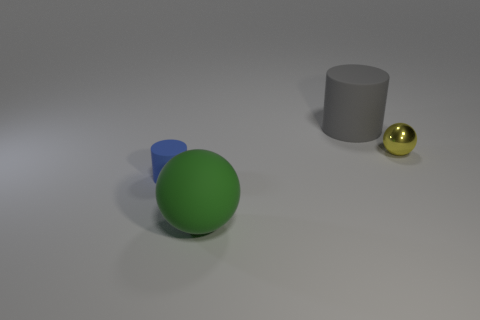Is there anything else that has the same color as the big matte ball?
Offer a terse response. No. What number of rubber things are tiny blue things or green spheres?
Make the answer very short. 2. What is the size of the thing that is both in front of the big gray matte cylinder and behind the small rubber cylinder?
Offer a very short reply. Small. There is a big object that is in front of the small blue cylinder; is there a tiny blue rubber cylinder that is on the left side of it?
Ensure brevity in your answer.  Yes. There is a big gray matte object; what number of small shiny balls are on the right side of it?
Provide a succinct answer. 1. There is a large rubber object that is the same shape as the small blue object; what color is it?
Ensure brevity in your answer.  Gray. Do the cylinder that is behind the small blue rubber cylinder and the tiny thing that is on the right side of the blue cylinder have the same material?
Keep it short and to the point. No. There is a thing that is both on the right side of the large sphere and to the left of the yellow object; what is its shape?
Make the answer very short. Cylinder. How many tiny gray shiny cylinders are there?
Give a very brief answer. 0. There is another thing that is the same shape as the small blue thing; what is its size?
Keep it short and to the point. Large. 